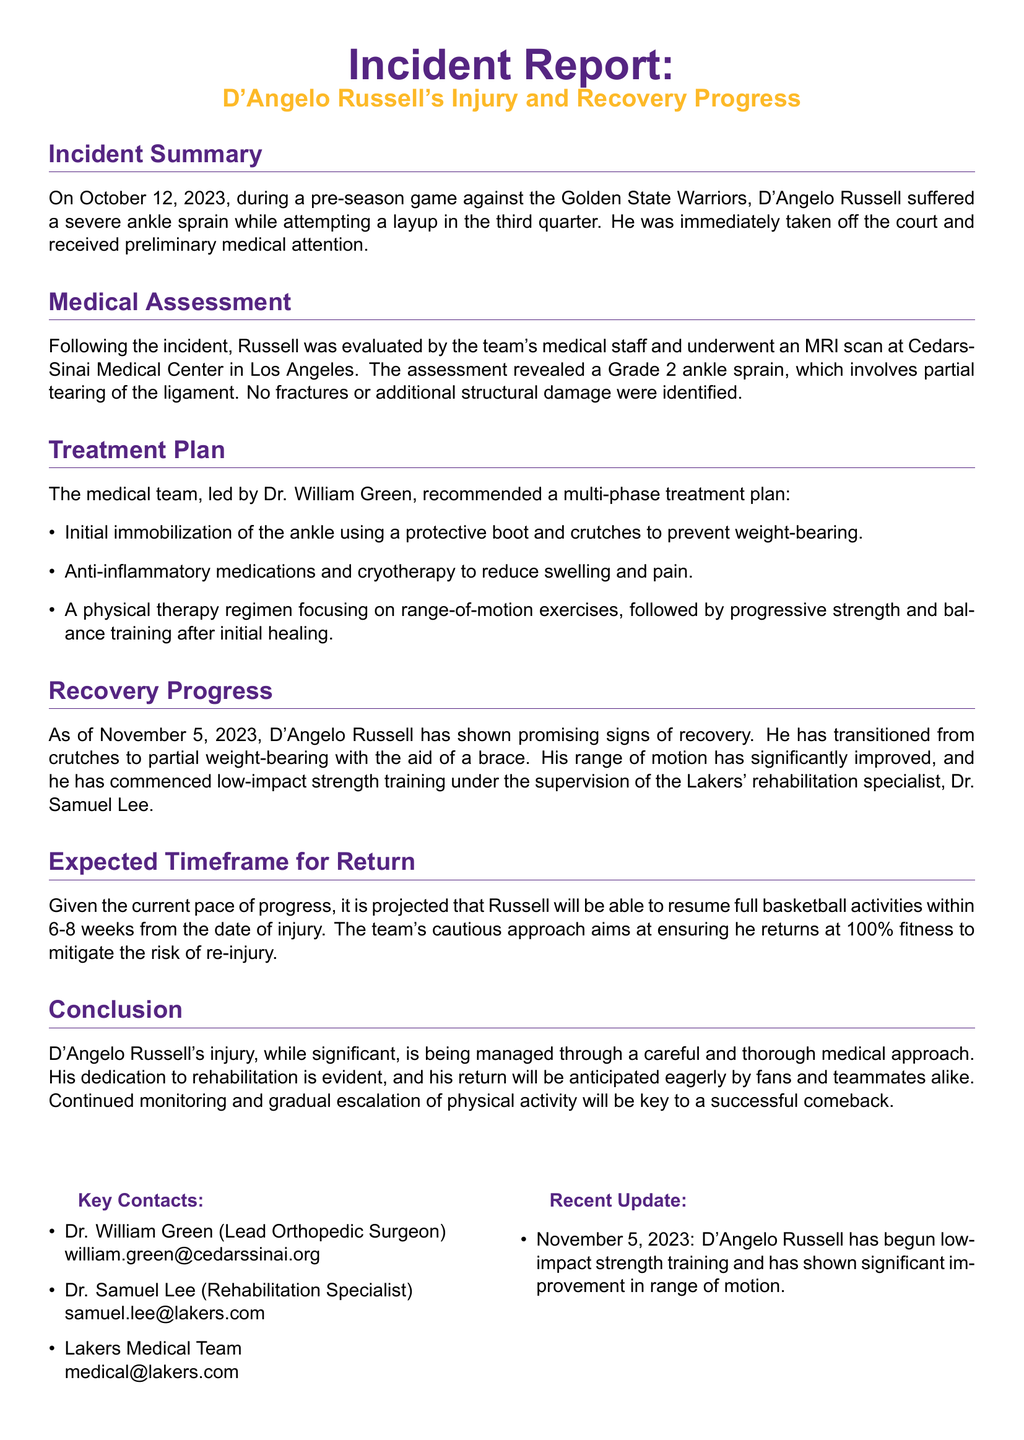What date did the injury occur? The injury occurred on October 12, 2023, during a pre-season game.
Answer: October 12, 2023 What type of injury did D'Angelo Russell sustain? The medical assessment revealed a Grade 2 ankle sprain, which involves partial tearing of the ligament.
Answer: Grade 2 ankle sprain Who is the lead orthopedic surgeon? The report lists Dr. William Green as the lead orthopedic surgeon.
Answer: Dr. William Green What is the expected timeframe for D'Angelo Russell's return? The expected timeframe for his return is 6-8 weeks from the date of injury.
Answer: 6-8 weeks What has D'Angelo Russell begun doing as part of his recovery? He has begun low-impact strength training under supervision as part of his recovery.
Answer: Low-impact strength training What was the result of D'Angelo Russell's MRI scan? The MRI scan revealed no fractures or additional structural damage.
Answer: No fractures or additional structural damage What type of treatment does the recovery plan include? The treatment plan includes anti-inflammatory medications and cryotherapy to reduce swelling and pain.
Answer: Anti-inflammatory medications and cryotherapy What is Dr. Samuel Lee's role in Russell's recovery? Dr. Samuel Lee is the rehabilitation specialist supervising Russell's training.
Answer: Rehabilitation specialist 